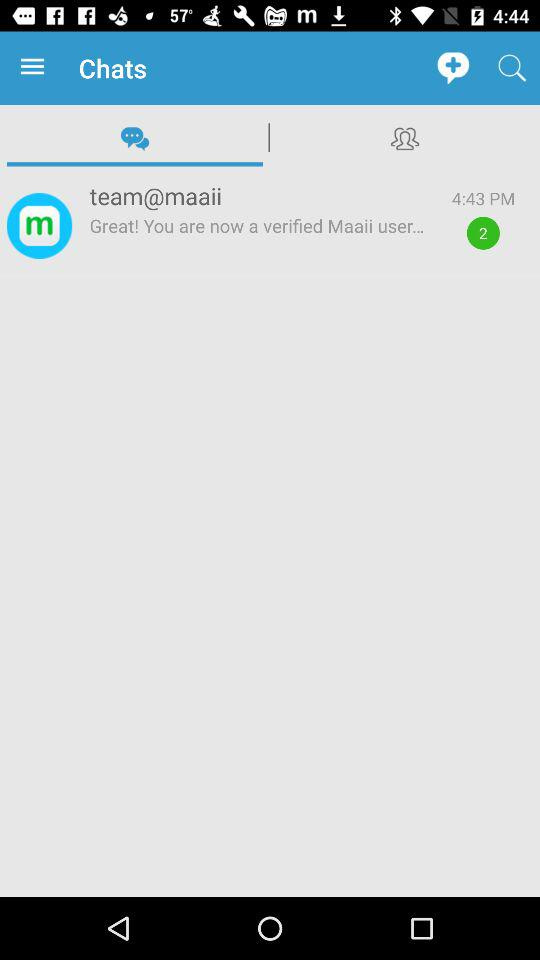How many unread messages does the user have?
Answer the question using a single word or phrase. 2 